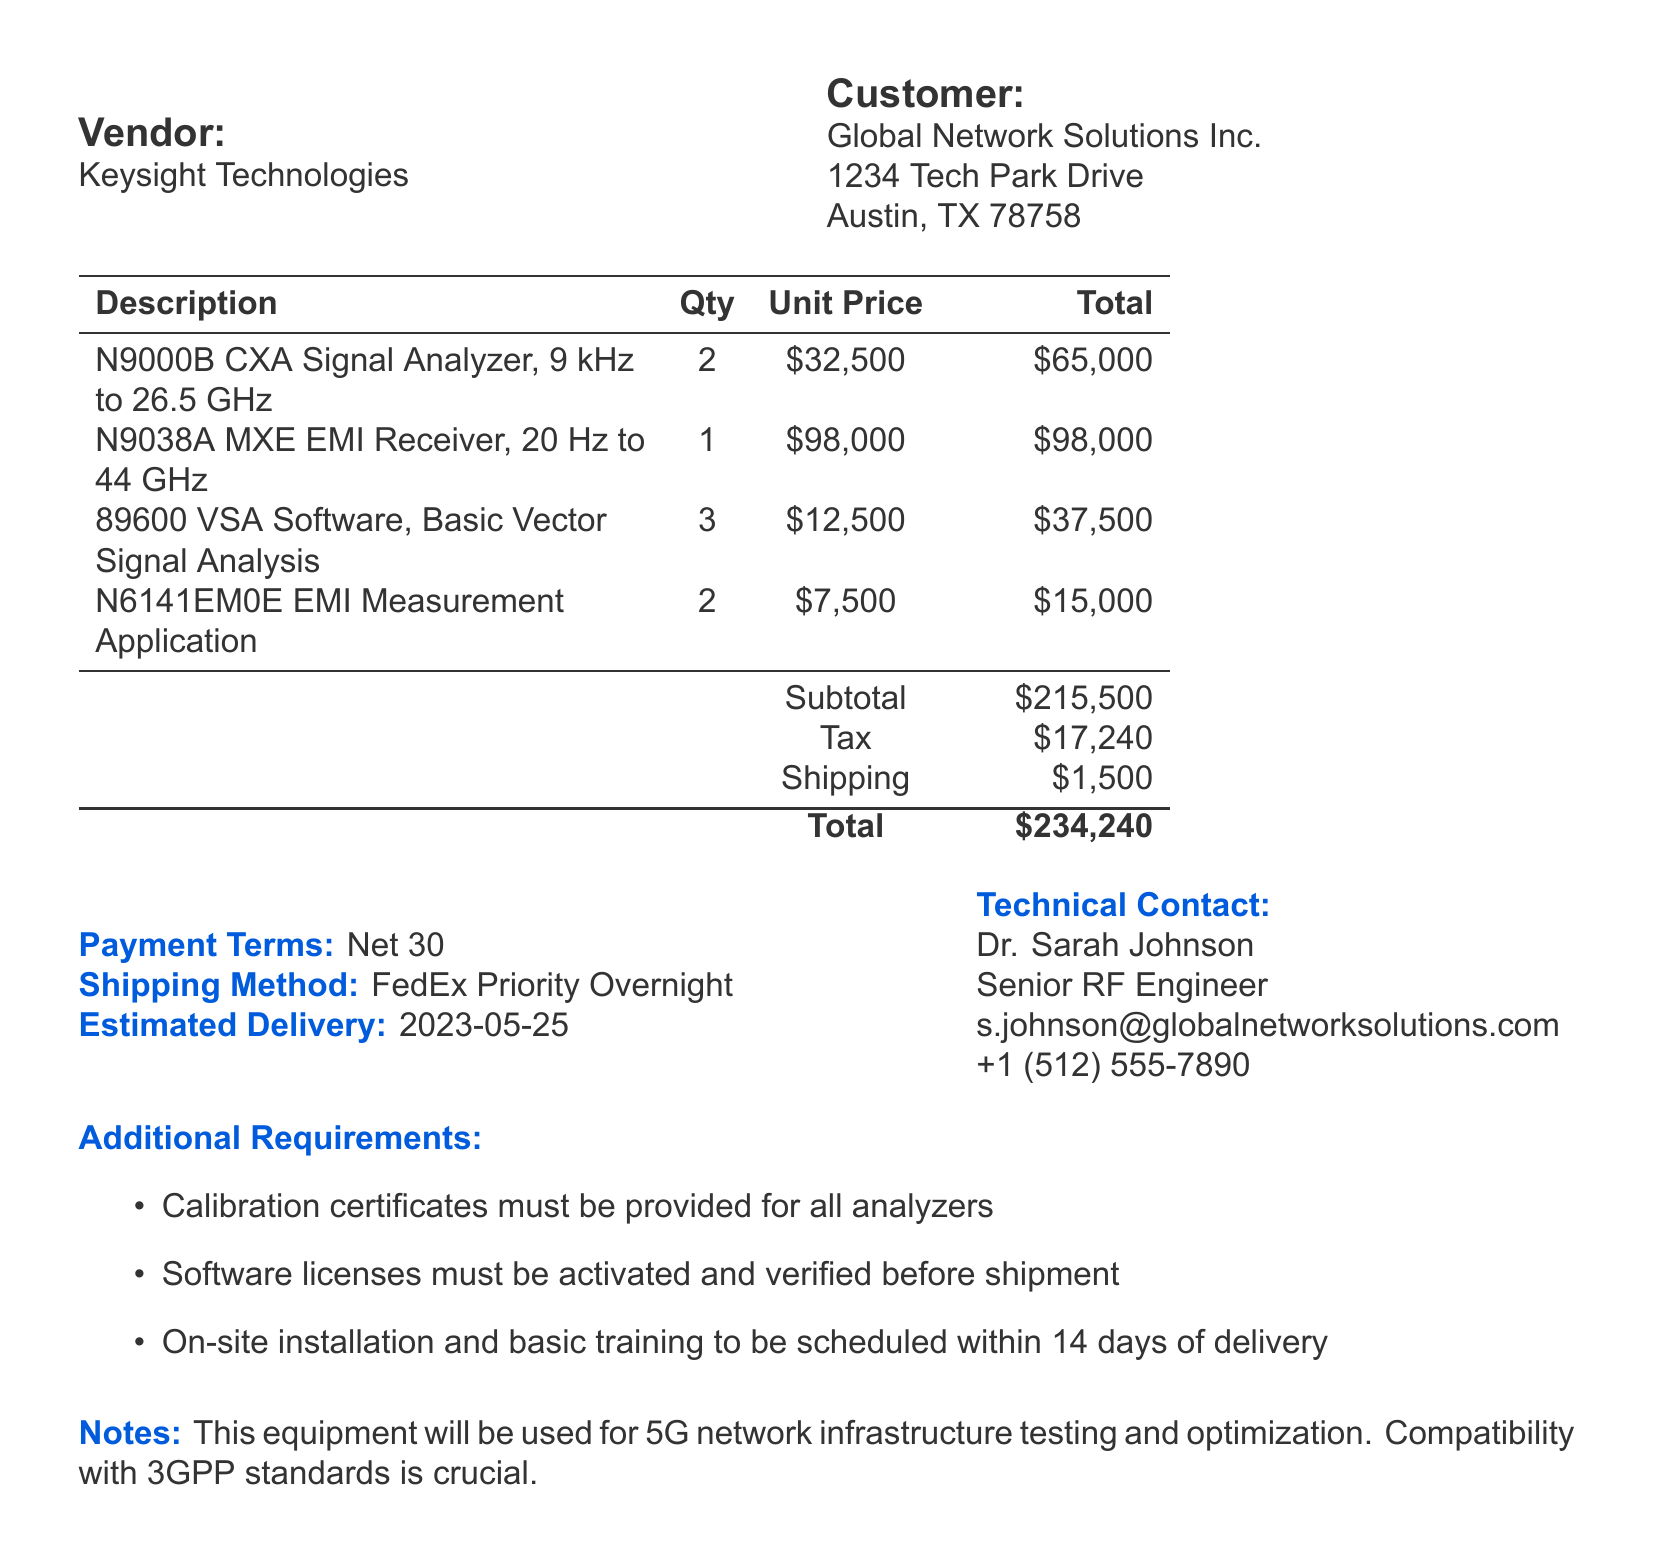what is the vendor name? The vendor name is stated in the document as Keysight Technologies.
Answer: Keysight Technologies what is the total amount of the purchase order? The total amount can be found in the summary at the end of the document, specifically labeled "Total."
Answer: $234,240 how many N9000B CXA Signal Analyzers are being purchased? The quantity of N9000B CXA Signal Analyzers is detailed in the itemized list section of the document.
Answer: 2 who is the technical contact person? The technical contact person's name is specified in the contact information section of the document.
Answer: Dr. Sarah Johnson what is the estimated delivery date? The estimated delivery date is listed under the delivery terms section of the document.
Answer: 2023-05-25 what should be provided for all analyzers? This information is included in the additional requirements section of the document.
Answer: Calibration certificates what are the software licenses required to be done before shipment? The document specifies requirements about software licenses under the additional requirements section.
Answer: Activated and verified how long after delivery should on-site installation and training be scheduled? The requirement for scheduling on-site installation and training is indicated in the additional requirements section.
Answer: Within 14 days 